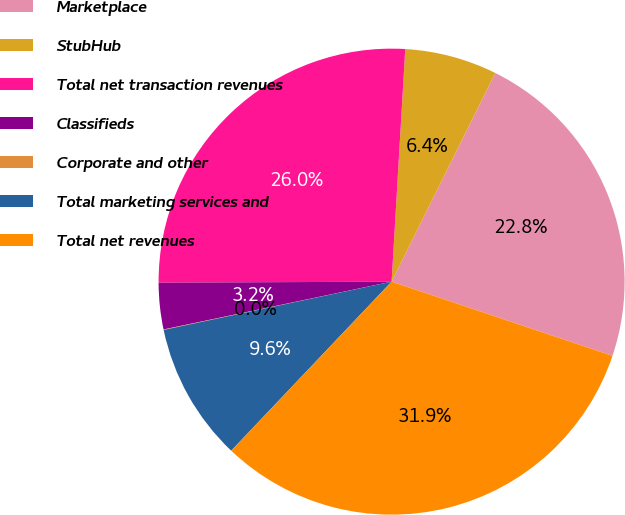<chart> <loc_0><loc_0><loc_500><loc_500><pie_chart><fcel>Marketplace<fcel>StubHub<fcel>Total net transaction revenues<fcel>Classifieds<fcel>Corporate and other<fcel>Total marketing services and<fcel>Total net revenues<nl><fcel>22.82%<fcel>6.41%<fcel>26.01%<fcel>3.22%<fcel>0.03%<fcel>9.6%<fcel>31.93%<nl></chart> 